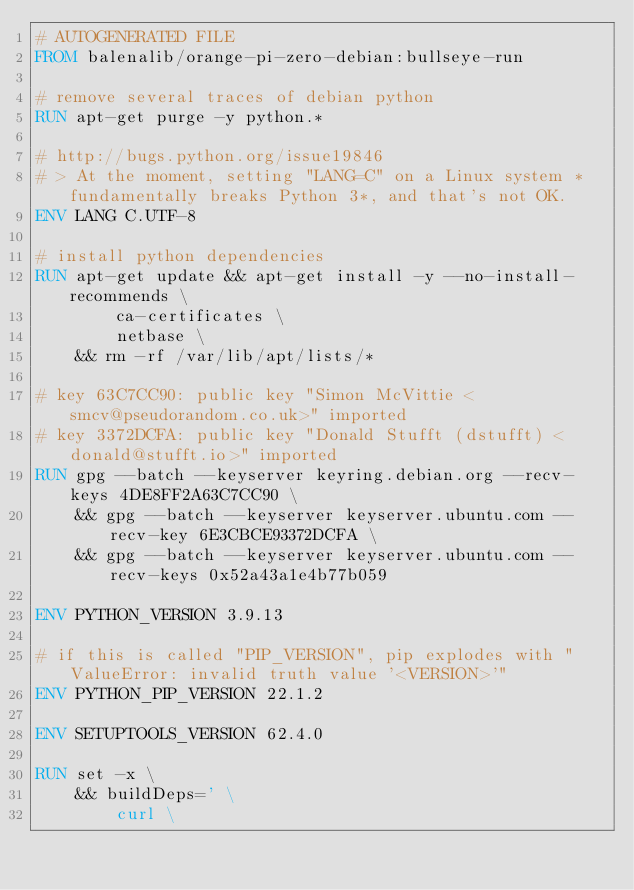<code> <loc_0><loc_0><loc_500><loc_500><_Dockerfile_># AUTOGENERATED FILE
FROM balenalib/orange-pi-zero-debian:bullseye-run

# remove several traces of debian python
RUN apt-get purge -y python.*

# http://bugs.python.org/issue19846
# > At the moment, setting "LANG=C" on a Linux system *fundamentally breaks Python 3*, and that's not OK.
ENV LANG C.UTF-8

# install python dependencies
RUN apt-get update && apt-get install -y --no-install-recommends \
		ca-certificates \
		netbase \
	&& rm -rf /var/lib/apt/lists/*

# key 63C7CC90: public key "Simon McVittie <smcv@pseudorandom.co.uk>" imported
# key 3372DCFA: public key "Donald Stufft (dstufft) <donald@stufft.io>" imported
RUN gpg --batch --keyserver keyring.debian.org --recv-keys 4DE8FF2A63C7CC90 \
	&& gpg --batch --keyserver keyserver.ubuntu.com --recv-key 6E3CBCE93372DCFA \
	&& gpg --batch --keyserver keyserver.ubuntu.com --recv-keys 0x52a43a1e4b77b059

ENV PYTHON_VERSION 3.9.13

# if this is called "PIP_VERSION", pip explodes with "ValueError: invalid truth value '<VERSION>'"
ENV PYTHON_PIP_VERSION 22.1.2

ENV SETUPTOOLS_VERSION 62.4.0

RUN set -x \
	&& buildDeps=' \
		curl \</code> 